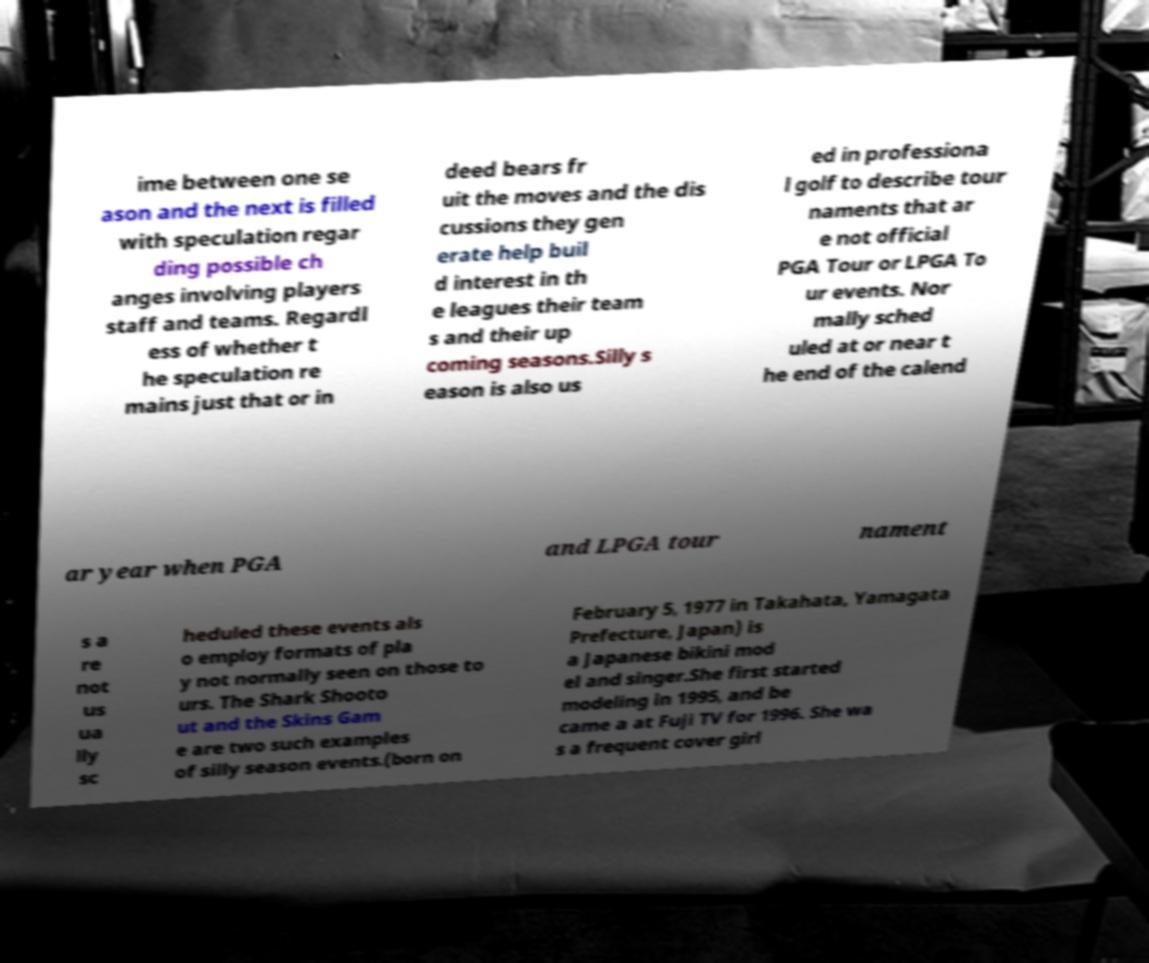For documentation purposes, I need the text within this image transcribed. Could you provide that? ime between one se ason and the next is filled with speculation regar ding possible ch anges involving players staff and teams. Regardl ess of whether t he speculation re mains just that or in deed bears fr uit the moves and the dis cussions they gen erate help buil d interest in th e leagues their team s and their up coming seasons.Silly s eason is also us ed in professiona l golf to describe tour naments that ar e not official PGA Tour or LPGA To ur events. Nor mally sched uled at or near t he end of the calend ar year when PGA and LPGA tour nament s a re not us ua lly sc heduled these events als o employ formats of pla y not normally seen on those to urs. The Shark Shooto ut and the Skins Gam e are two such examples of silly season events.(born on February 5, 1977 in Takahata, Yamagata Prefecture, Japan) is a Japanese bikini mod el and singer.She first started modeling in 1995, and be came a at Fuji TV for 1996. She wa s a frequent cover girl 